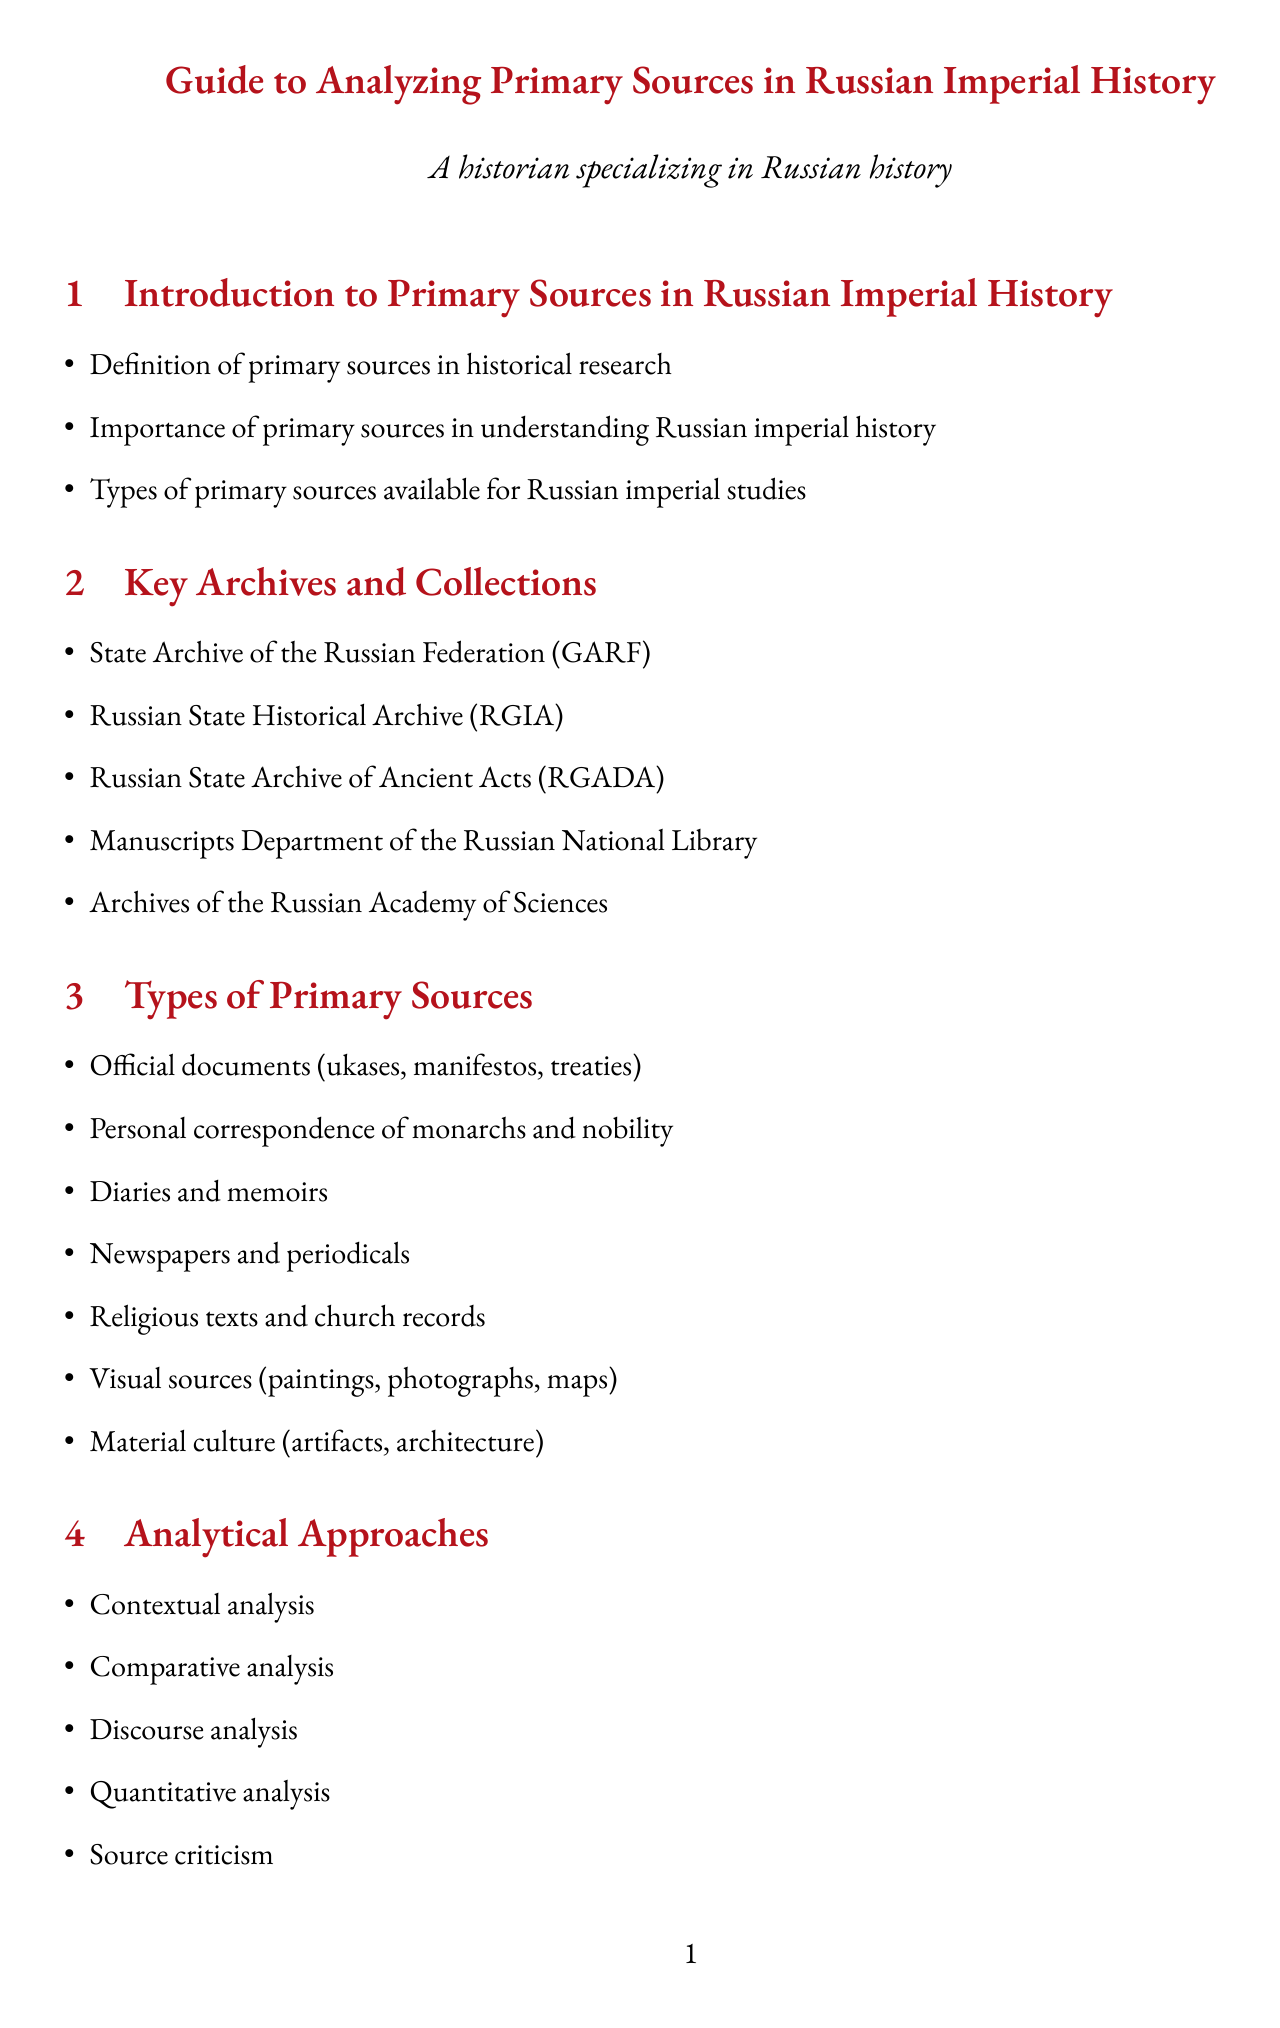What is the title of the document? The title is provided prominently at the beginning of the document.
Answer: Guide to Analyzing Primary Sources in Russian Imperial History How many key archives are listed? The document enumerates several key archives in a specific section.
Answer: Five What type of primary source includes letters from nobles? The document categorizes specific types of primary sources available for analysis.
Answer: Personal correspondence of monarchs and nobility What analytical approach involves examining texts in their historical context? This type of analysis relates to understanding the environment around the source material.
Answer: Contextual analysis Which case study examines correspondence with Voltaire? The document outlines several case studies focusing on different historical figures.
Answer: Catherine the Great's correspondence with Voltaire What is one challenge mentioned in working with Russian imperial sources? The document lists various challenges faced while analyzing these historical materials.
Answer: Language barriers (Old Church Slavonic, 18th-19th century Russian) Name one digital resource mentioned in the document. The document mentions specific digital resources that can aid in research.
Answer: Online databases (e.g., Pravo.gov.ru for legal documents) What broader historical theme involves class relations in imperial Russia? The document connects sources to overarching themes in Russian history.
Answer: Social hierarchy and class relations in imperial Russia 